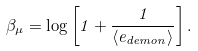<formula> <loc_0><loc_0><loc_500><loc_500>\beta _ { \mu } = \log \left [ 1 + \frac { 1 } { \langle e _ { d e m o n } \rangle } \right ] .</formula> 